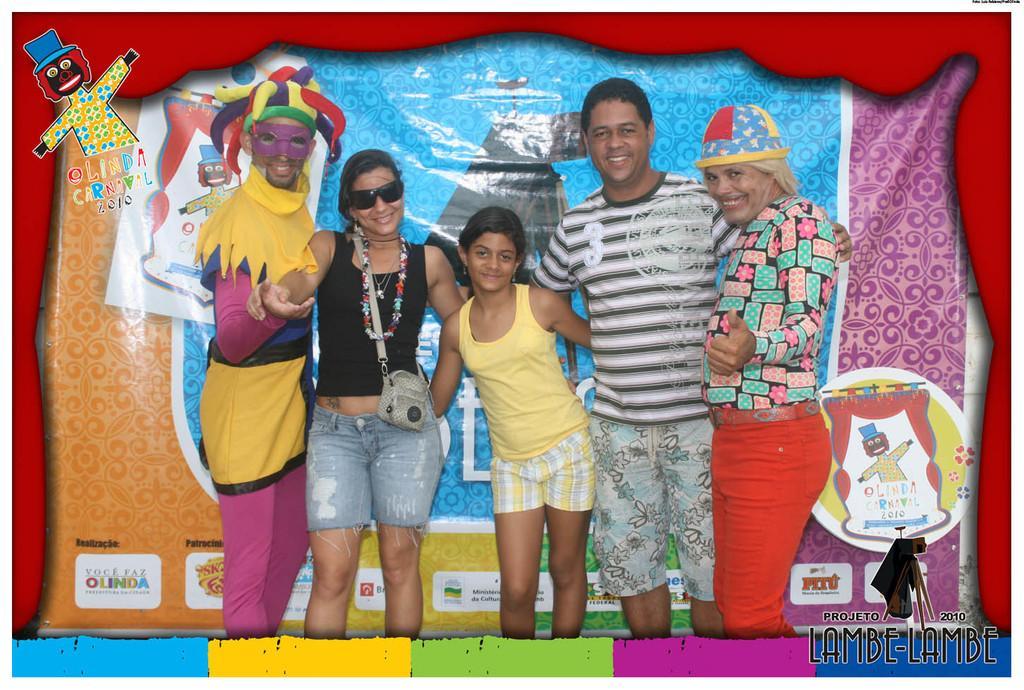Can you describe this image briefly? In the image in the center, we can see a few people are standing and they are smiling and they are in different costumes. In the background there is a banner. 